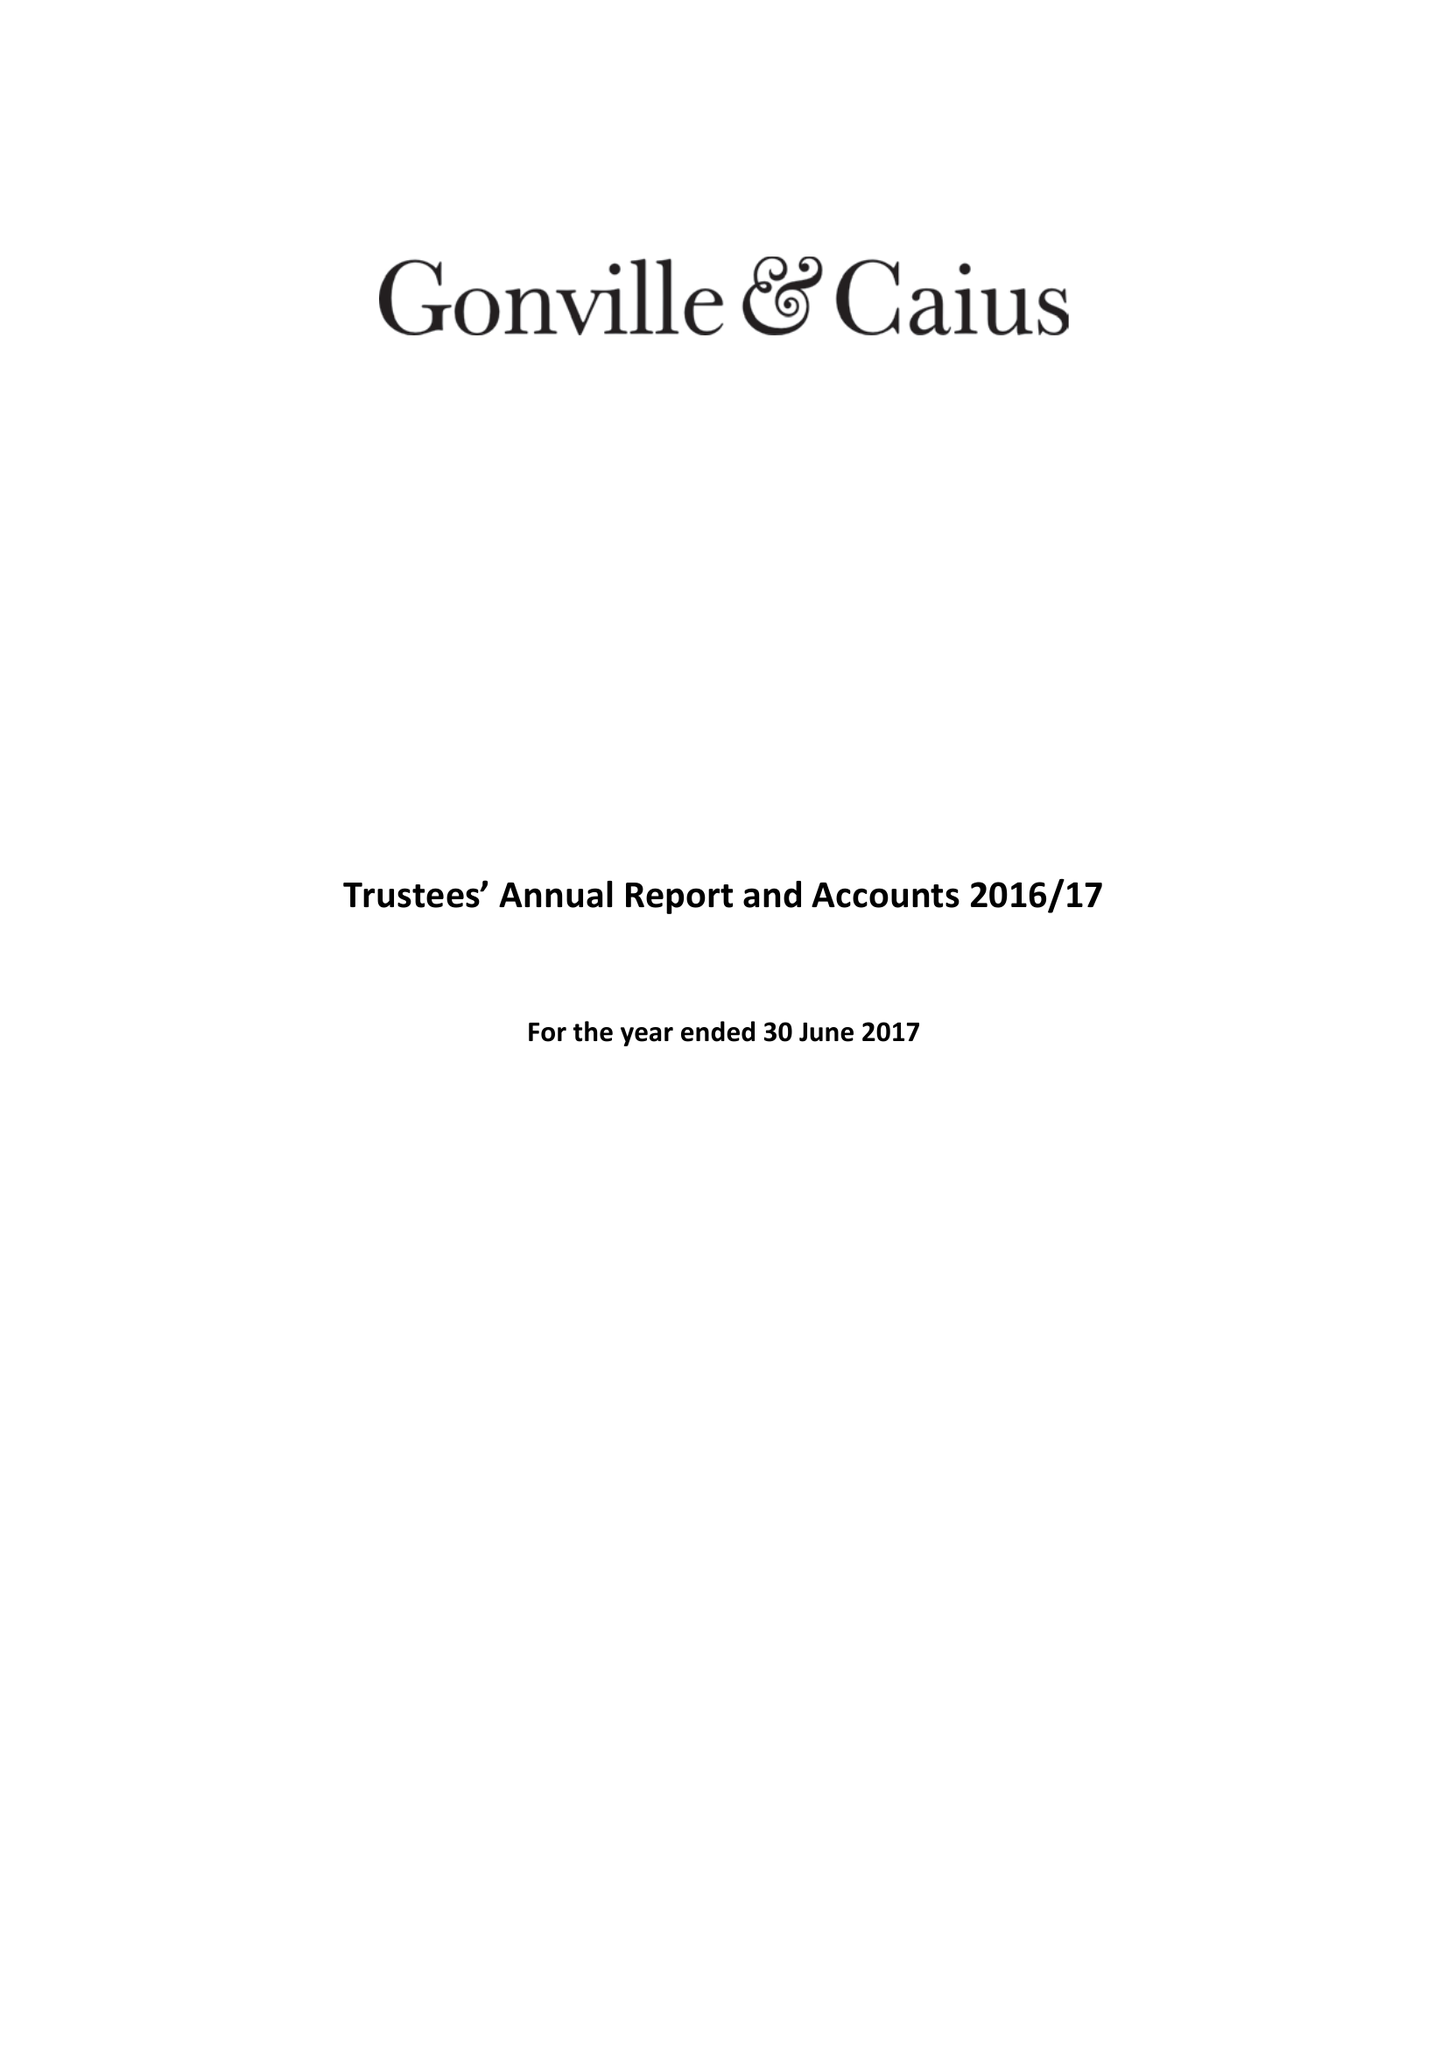What is the value for the spending_annually_in_british_pounds?
Answer the question using a single word or phrase. 17564000.00 